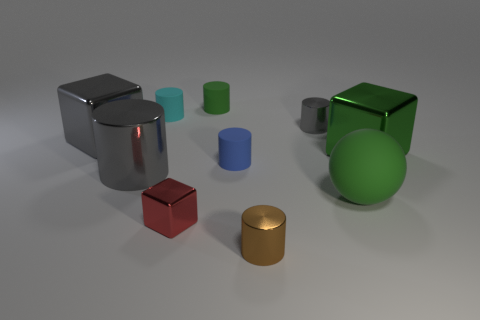Subtract all cyan cylinders. How many cylinders are left? 5 Subtract all blue cylinders. How many cylinders are left? 5 Subtract all blue cylinders. Subtract all blue cubes. How many cylinders are left? 5 Subtract all cylinders. How many objects are left? 4 Add 9 tiny cyan things. How many tiny cyan things are left? 10 Add 8 large gray cylinders. How many large gray cylinders exist? 9 Subtract 0 brown blocks. How many objects are left? 10 Subtract all metallic things. Subtract all big gray metal objects. How many objects are left? 2 